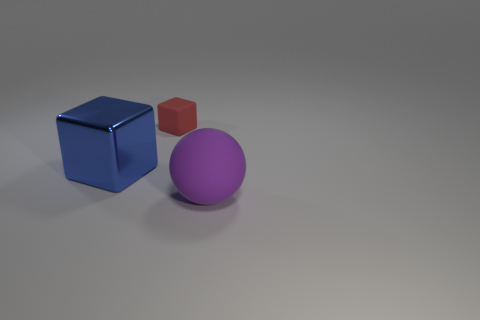The large thing that is behind the purple sphere that is in front of the big blue thing is what shape?
Make the answer very short. Cube. There is a object on the left side of the small cube; what is its color?
Make the answer very short. Blue. What is the size of the block that is made of the same material as the large ball?
Make the answer very short. Small. What size is the red matte thing that is the same shape as the blue thing?
Your answer should be very brief. Small. Is there a big green metal cylinder?
Give a very brief answer. No. What number of things are things that are to the left of the big purple matte sphere or big matte things?
Make the answer very short. 3. There is a purple sphere that is the same size as the shiny cube; what is it made of?
Offer a very short reply. Rubber. There is a large thing that is behind the matte thing right of the small cube; what is its color?
Your answer should be compact. Blue. There is a ball; how many red objects are to the right of it?
Offer a very short reply. 0. The rubber ball has what color?
Your response must be concise. Purple. 